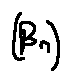<formula> <loc_0><loc_0><loc_500><loc_500>( \beta _ { n } )</formula> 